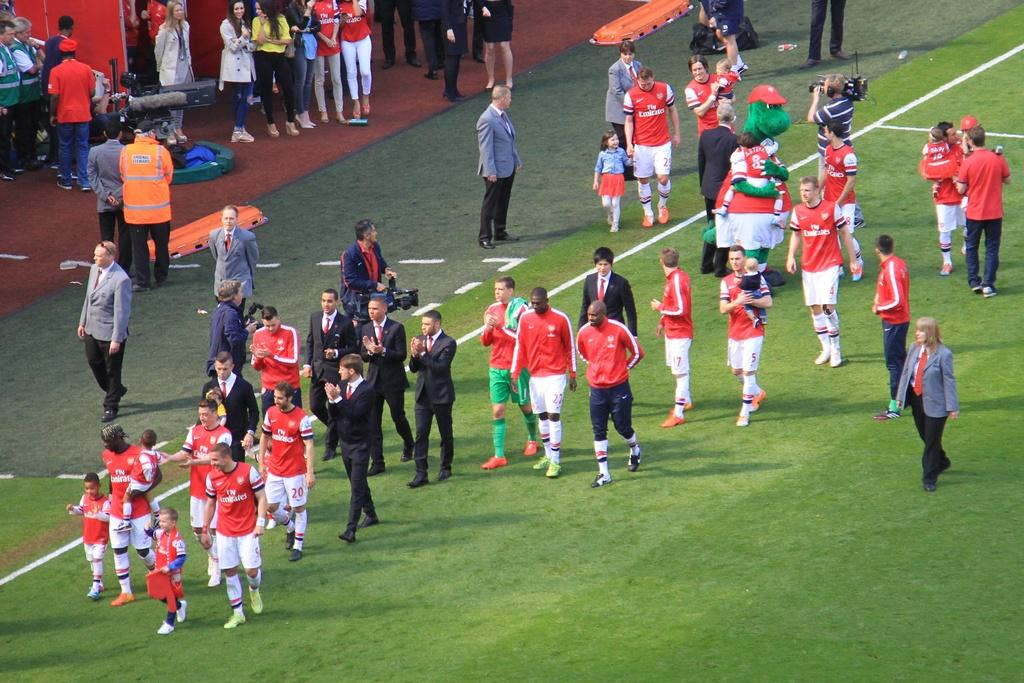Provide a one-sentence caption for the provided image. a group of players with fly emirates written on their shirts. 